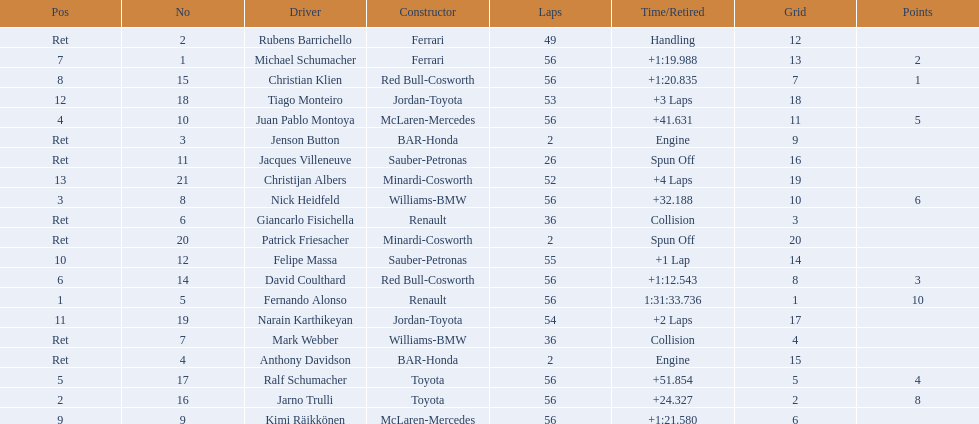Help me parse the entirety of this table. {'header': ['Pos', 'No', 'Driver', 'Constructor', 'Laps', 'Time/Retired', 'Grid', 'Points'], 'rows': [['Ret', '2', 'Rubens Barrichello', 'Ferrari', '49', 'Handling', '12', ''], ['7', '1', 'Michael Schumacher', 'Ferrari', '56', '+1:19.988', '13', '2'], ['8', '15', 'Christian Klien', 'Red Bull-Cosworth', '56', '+1:20.835', '7', '1'], ['12', '18', 'Tiago Monteiro', 'Jordan-Toyota', '53', '+3 Laps', '18', ''], ['4', '10', 'Juan Pablo Montoya', 'McLaren-Mercedes', '56', '+41.631', '11', '5'], ['Ret', '3', 'Jenson Button', 'BAR-Honda', '2', 'Engine', '9', ''], ['Ret', '11', 'Jacques Villeneuve', 'Sauber-Petronas', '26', 'Spun Off', '16', ''], ['13', '21', 'Christijan Albers', 'Minardi-Cosworth', '52', '+4 Laps', '19', ''], ['3', '8', 'Nick Heidfeld', 'Williams-BMW', '56', '+32.188', '10', '6'], ['Ret', '6', 'Giancarlo Fisichella', 'Renault', '36', 'Collision', '3', ''], ['Ret', '20', 'Patrick Friesacher', 'Minardi-Cosworth', '2', 'Spun Off', '20', ''], ['10', '12', 'Felipe Massa', 'Sauber-Petronas', '55', '+1 Lap', '14', ''], ['6', '14', 'David Coulthard', 'Red Bull-Cosworth', '56', '+1:12.543', '8', '3'], ['1', '5', 'Fernando Alonso', 'Renault', '56', '1:31:33.736', '1', '10'], ['11', '19', 'Narain Karthikeyan', 'Jordan-Toyota', '54', '+2 Laps', '17', ''], ['Ret', '7', 'Mark Webber', 'Williams-BMW', '36', 'Collision', '4', ''], ['Ret', '4', 'Anthony Davidson', 'BAR-Honda', '2', 'Engine', '15', ''], ['5', '17', 'Ralf Schumacher', 'Toyota', '56', '+51.854', '5', '4'], ['2', '16', 'Jarno Trulli', 'Toyota', '56', '+24.327', '2', '8'], ['9', '9', 'Kimi Räikkönen', 'McLaren-Mercedes', '56', '+1:21.580', '6', '']]} What place did fernando alonso finish? 1. How long did it take alonso to finish the race? 1:31:33.736. 